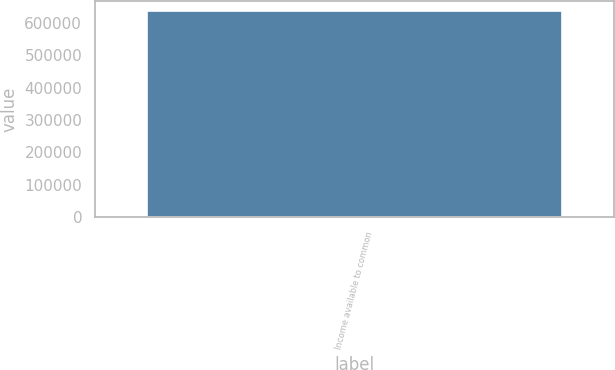Convert chart. <chart><loc_0><loc_0><loc_500><loc_500><bar_chart><fcel>Income available to common<nl><fcel>636484<nl></chart> 